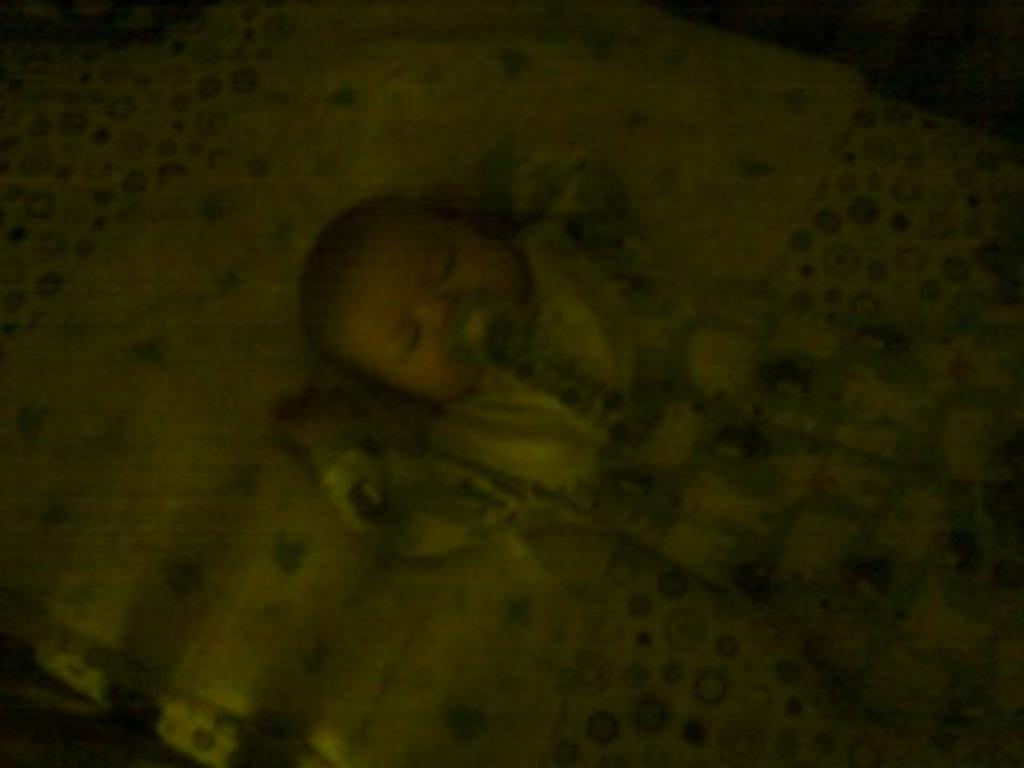What is the overall lighting condition in the image? The image appears to be dark. What can be seen in the image? There is a baby in the image. Where is the baby located? The baby is sleeping on a bed. What type of badge is the baby wearing in the image? There is no badge present in the image; the baby is sleeping on a bed. What card game is being played by the baby in the image? There is no card game or card present in the image; the baby is sleeping on a bed. 